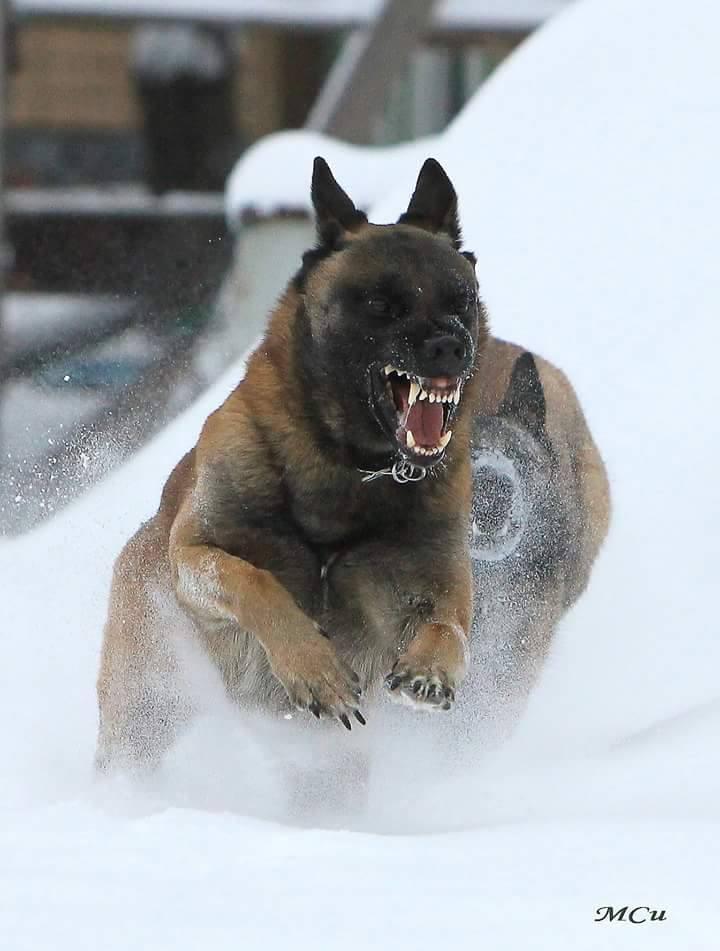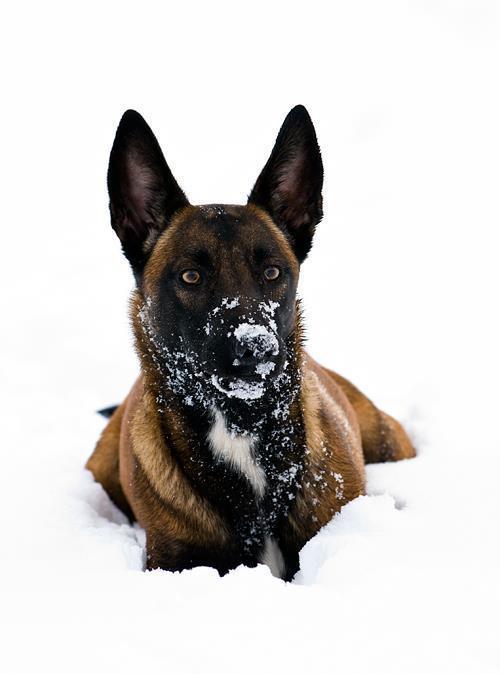The first image is the image on the left, the second image is the image on the right. Analyze the images presented: Is the assertion "Right image shows a camera-facing german shepherd dog with snow on its face." valid? Answer yes or no. Yes. The first image is the image on the left, the second image is the image on the right. Considering the images on both sides, is "A single dog is lying down alone in the image on the right." valid? Answer yes or no. Yes. 